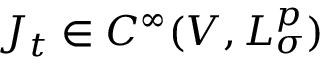<formula> <loc_0><loc_0><loc_500><loc_500>J _ { t } \in C ^ { \infty } ( V , L _ { \sigma } ^ { p } )</formula> 